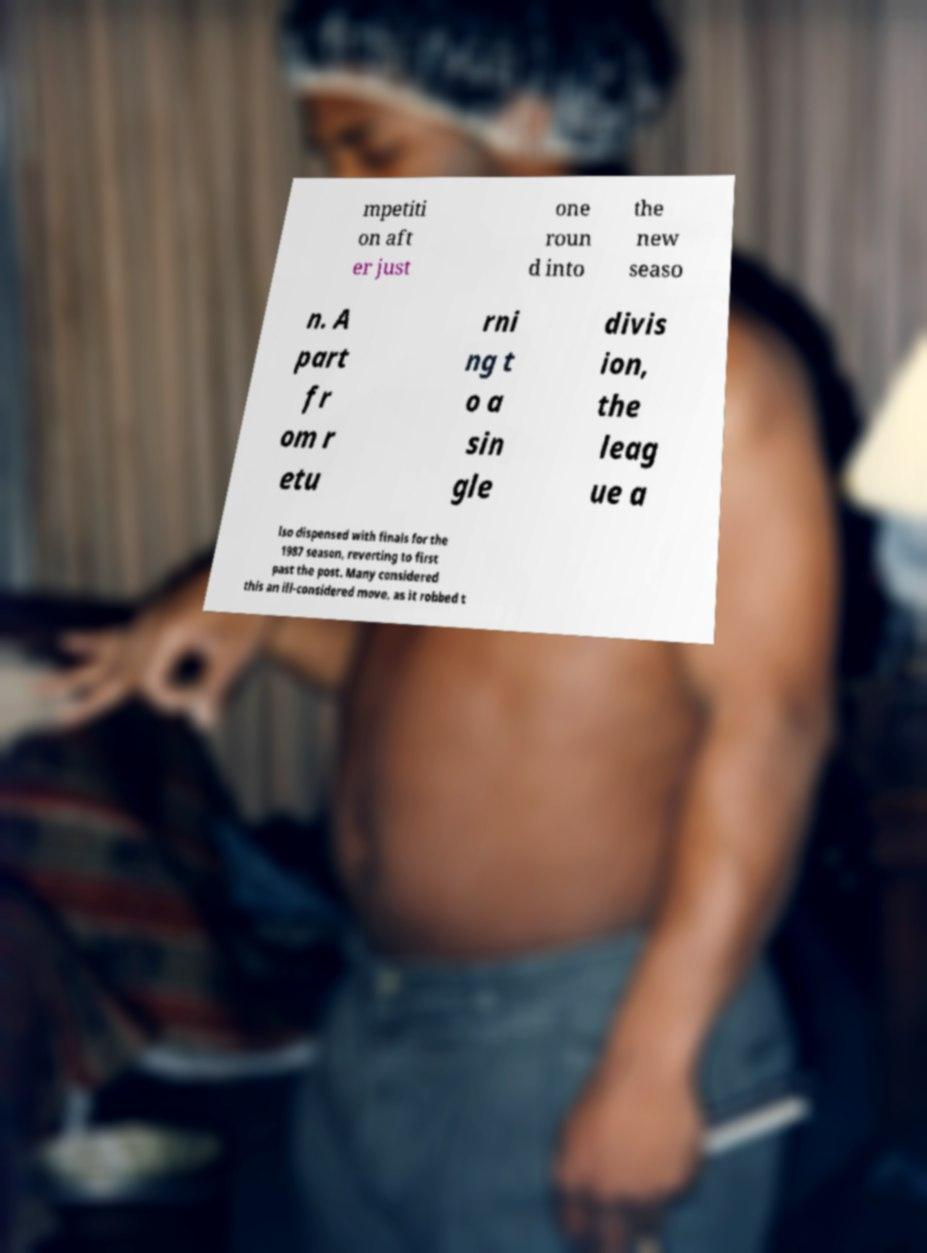For documentation purposes, I need the text within this image transcribed. Could you provide that? mpetiti on aft er just one roun d into the new seaso n. A part fr om r etu rni ng t o a sin gle divis ion, the leag ue a lso dispensed with finals for the 1987 season, reverting to first past the post. Many considered this an ill-considered move, as it robbed t 